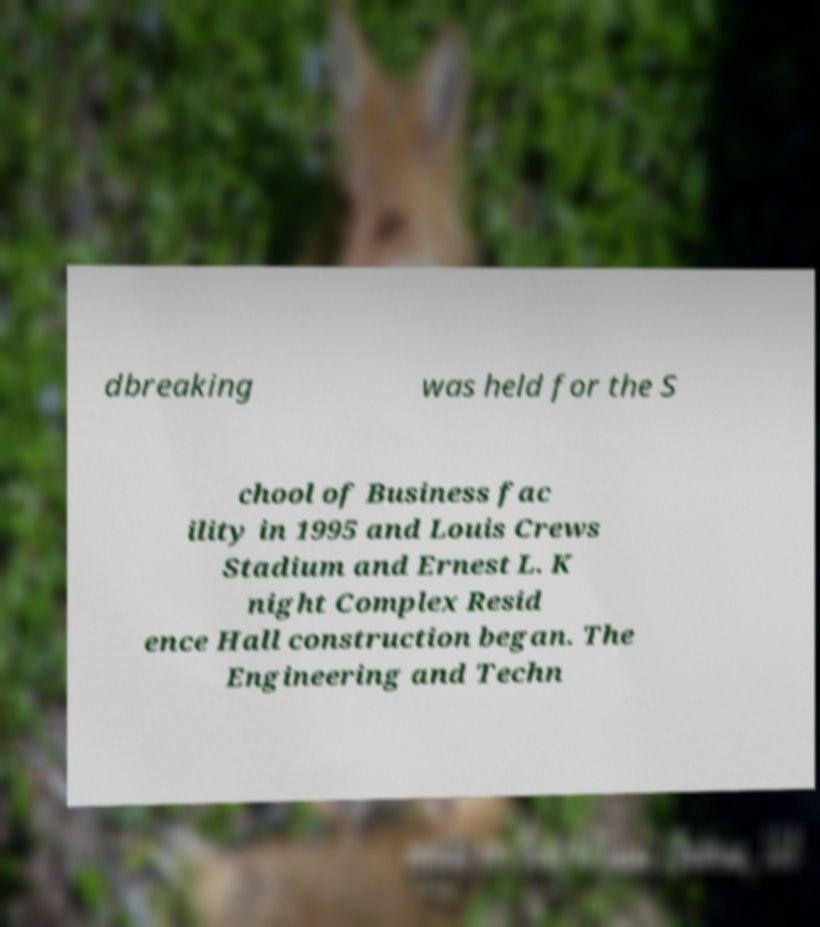Could you extract and type out the text from this image? dbreaking was held for the S chool of Business fac ility in 1995 and Louis Crews Stadium and Ernest L. K night Complex Resid ence Hall construction began. The Engineering and Techn 